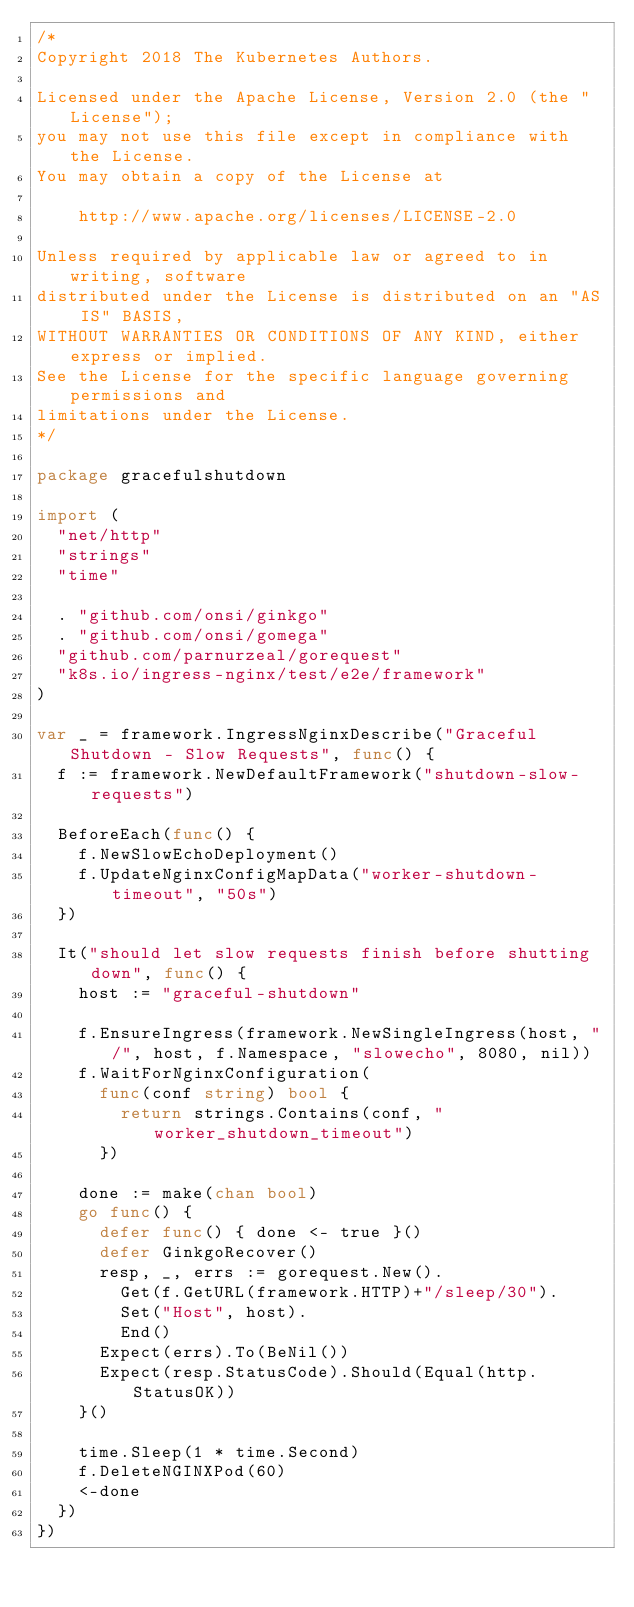Convert code to text. <code><loc_0><loc_0><loc_500><loc_500><_Go_>/*
Copyright 2018 The Kubernetes Authors.

Licensed under the Apache License, Version 2.0 (the "License");
you may not use this file except in compliance with the License.
You may obtain a copy of the License at

    http://www.apache.org/licenses/LICENSE-2.0

Unless required by applicable law or agreed to in writing, software
distributed under the License is distributed on an "AS IS" BASIS,
WITHOUT WARRANTIES OR CONDITIONS OF ANY KIND, either express or implied.
See the License for the specific language governing permissions and
limitations under the License.
*/

package gracefulshutdown

import (
	"net/http"
	"strings"
	"time"

	. "github.com/onsi/ginkgo"
	. "github.com/onsi/gomega"
	"github.com/parnurzeal/gorequest"
	"k8s.io/ingress-nginx/test/e2e/framework"
)

var _ = framework.IngressNginxDescribe("Graceful Shutdown - Slow Requests", func() {
	f := framework.NewDefaultFramework("shutdown-slow-requests")

	BeforeEach(func() {
		f.NewSlowEchoDeployment()
		f.UpdateNginxConfigMapData("worker-shutdown-timeout", "50s")
	})

	It("should let slow requests finish before shutting down", func() {
		host := "graceful-shutdown"

		f.EnsureIngress(framework.NewSingleIngress(host, "/", host, f.Namespace, "slowecho", 8080, nil))
		f.WaitForNginxConfiguration(
			func(conf string) bool {
				return strings.Contains(conf, "worker_shutdown_timeout")
			})

		done := make(chan bool)
		go func() {
			defer func() { done <- true }()
			defer GinkgoRecover()
			resp, _, errs := gorequest.New().
				Get(f.GetURL(framework.HTTP)+"/sleep/30").
				Set("Host", host).
				End()
			Expect(errs).To(BeNil())
			Expect(resp.StatusCode).Should(Equal(http.StatusOK))
		}()

		time.Sleep(1 * time.Second)
		f.DeleteNGINXPod(60)
		<-done
	})
})
</code> 